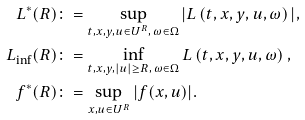<formula> <loc_0><loc_0><loc_500><loc_500>L ^ { * } ( R ) & \colon = \sup _ { t , x , y , u \in U ^ { R } , \, \omega \in \Omega } | L \left ( t , x , y , u , \omega \right ) | , \\ L _ { \inf } ( R ) & \colon = \inf _ { t , x , y , | u | \geq R , \, \omega \in \Omega } L \left ( t , x , y , u , \omega \right ) , \\ f ^ { * } ( R ) & \colon = \sup _ { x , u \in U ^ { R } } | f ( x , u ) | .</formula> 